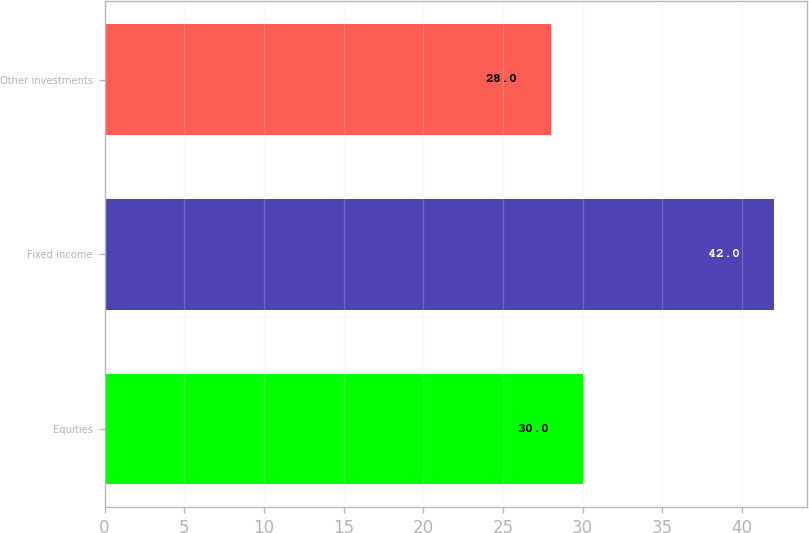Convert chart to OTSL. <chart><loc_0><loc_0><loc_500><loc_500><bar_chart><fcel>Equities<fcel>Fixed income<fcel>Other investments<nl><fcel>30<fcel>42<fcel>28<nl></chart> 